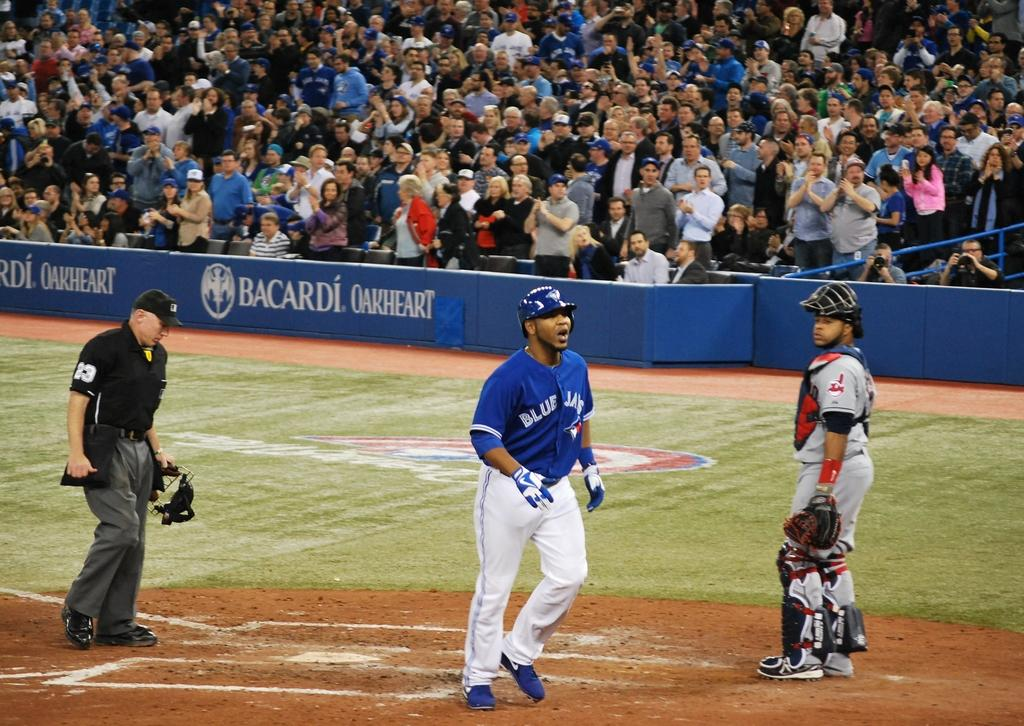Provide a one-sentence caption for the provided image. A baseball player for the Blue Jay's is standing near a base. 